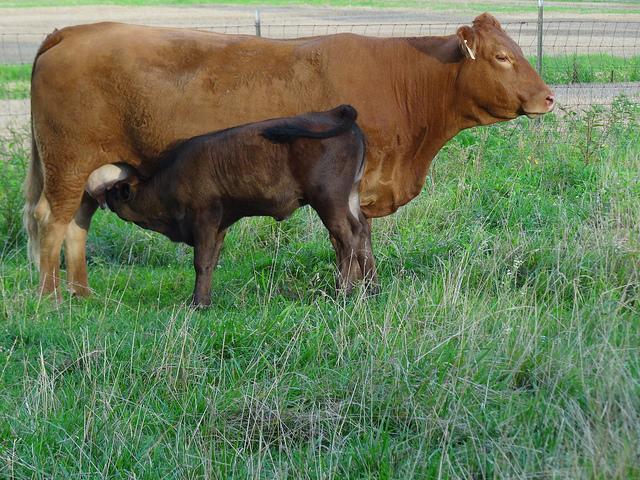How many adult animals in this photo?
Give a very brief answer. 1. How many cows are in the photo?
Give a very brief answer. 2. How many horses are in the picture?
Give a very brief answer. 0. 